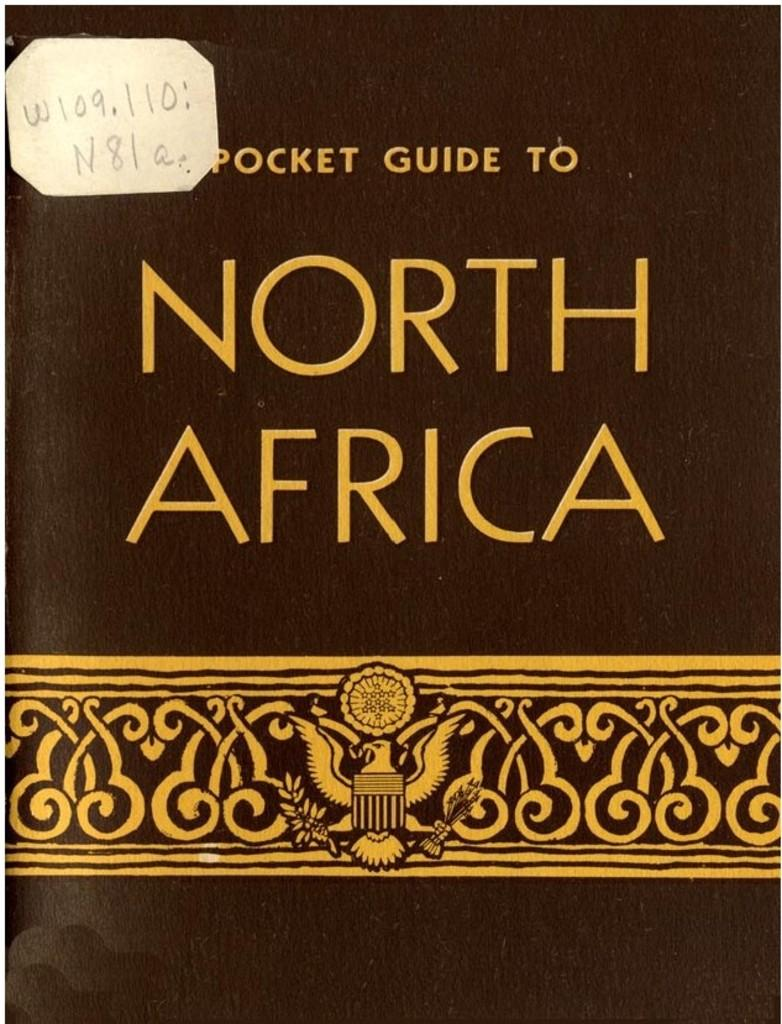<image>
Create a compact narrative representing the image presented. Brown book called "Pocket Guide to North America" with a tiny sticker near the top. 